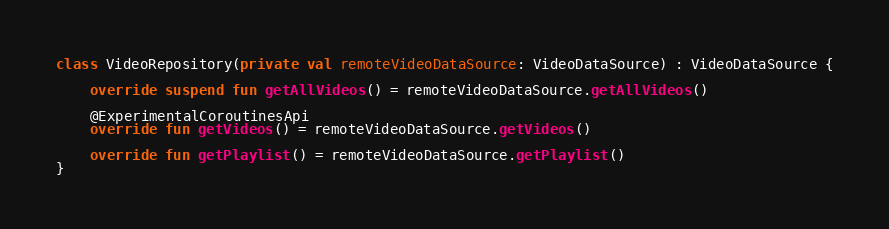Convert code to text. <code><loc_0><loc_0><loc_500><loc_500><_Kotlin_>class VideoRepository(private val remoteVideoDataSource: VideoDataSource) : VideoDataSource {

    override suspend fun getAllVideos() = remoteVideoDataSource.getAllVideos()

    @ExperimentalCoroutinesApi
    override fun getVideos() = remoteVideoDataSource.getVideos()

    override fun getPlaylist() = remoteVideoDataSource.getPlaylist()
}</code> 